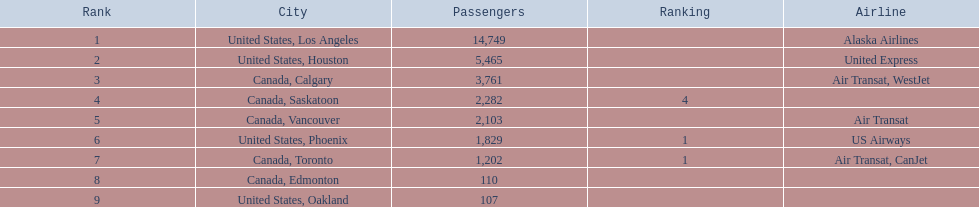Which cities had below 2,000 passengers? United States, Phoenix, Canada, Toronto, Canada, Edmonton, United States, Oakland. Of these cities, which had under 1,000 passengers? Canada, Edmonton, United States, Oakland. Of the cities in the earlier answer, which one had merely 107 passengers? United States, Oakland. 